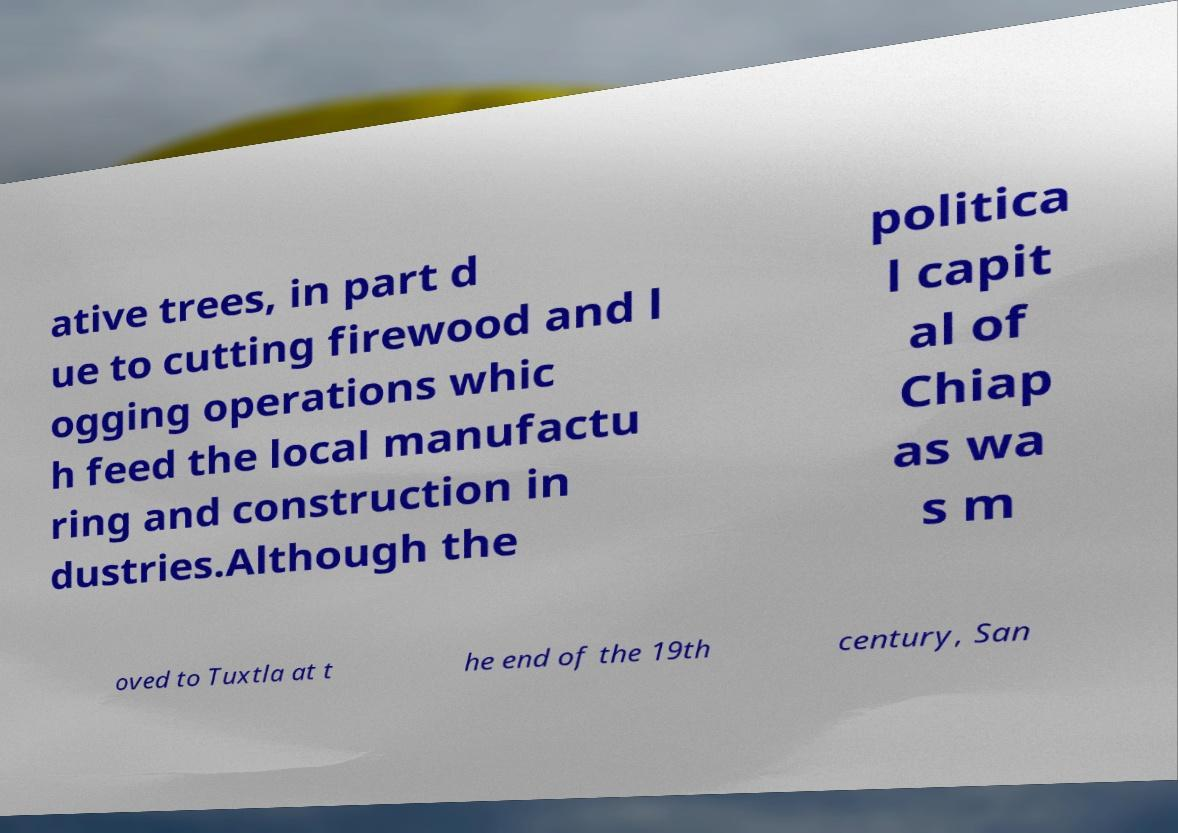Can you accurately transcribe the text from the provided image for me? ative trees, in part d ue to cutting firewood and l ogging operations whic h feed the local manufactu ring and construction in dustries.Although the politica l capit al of Chiap as wa s m oved to Tuxtla at t he end of the 19th century, San 